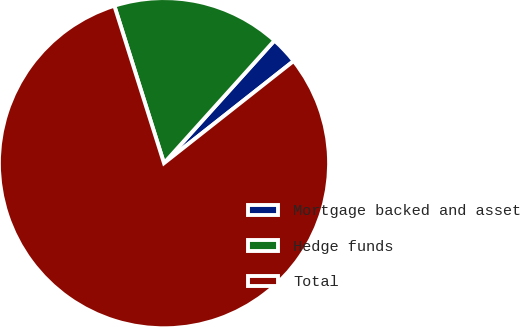Convert chart to OTSL. <chart><loc_0><loc_0><loc_500><loc_500><pie_chart><fcel>Mortgage backed and asset<fcel>Hedge funds<fcel>Total<nl><fcel>2.71%<fcel>16.53%<fcel>80.76%<nl></chart> 